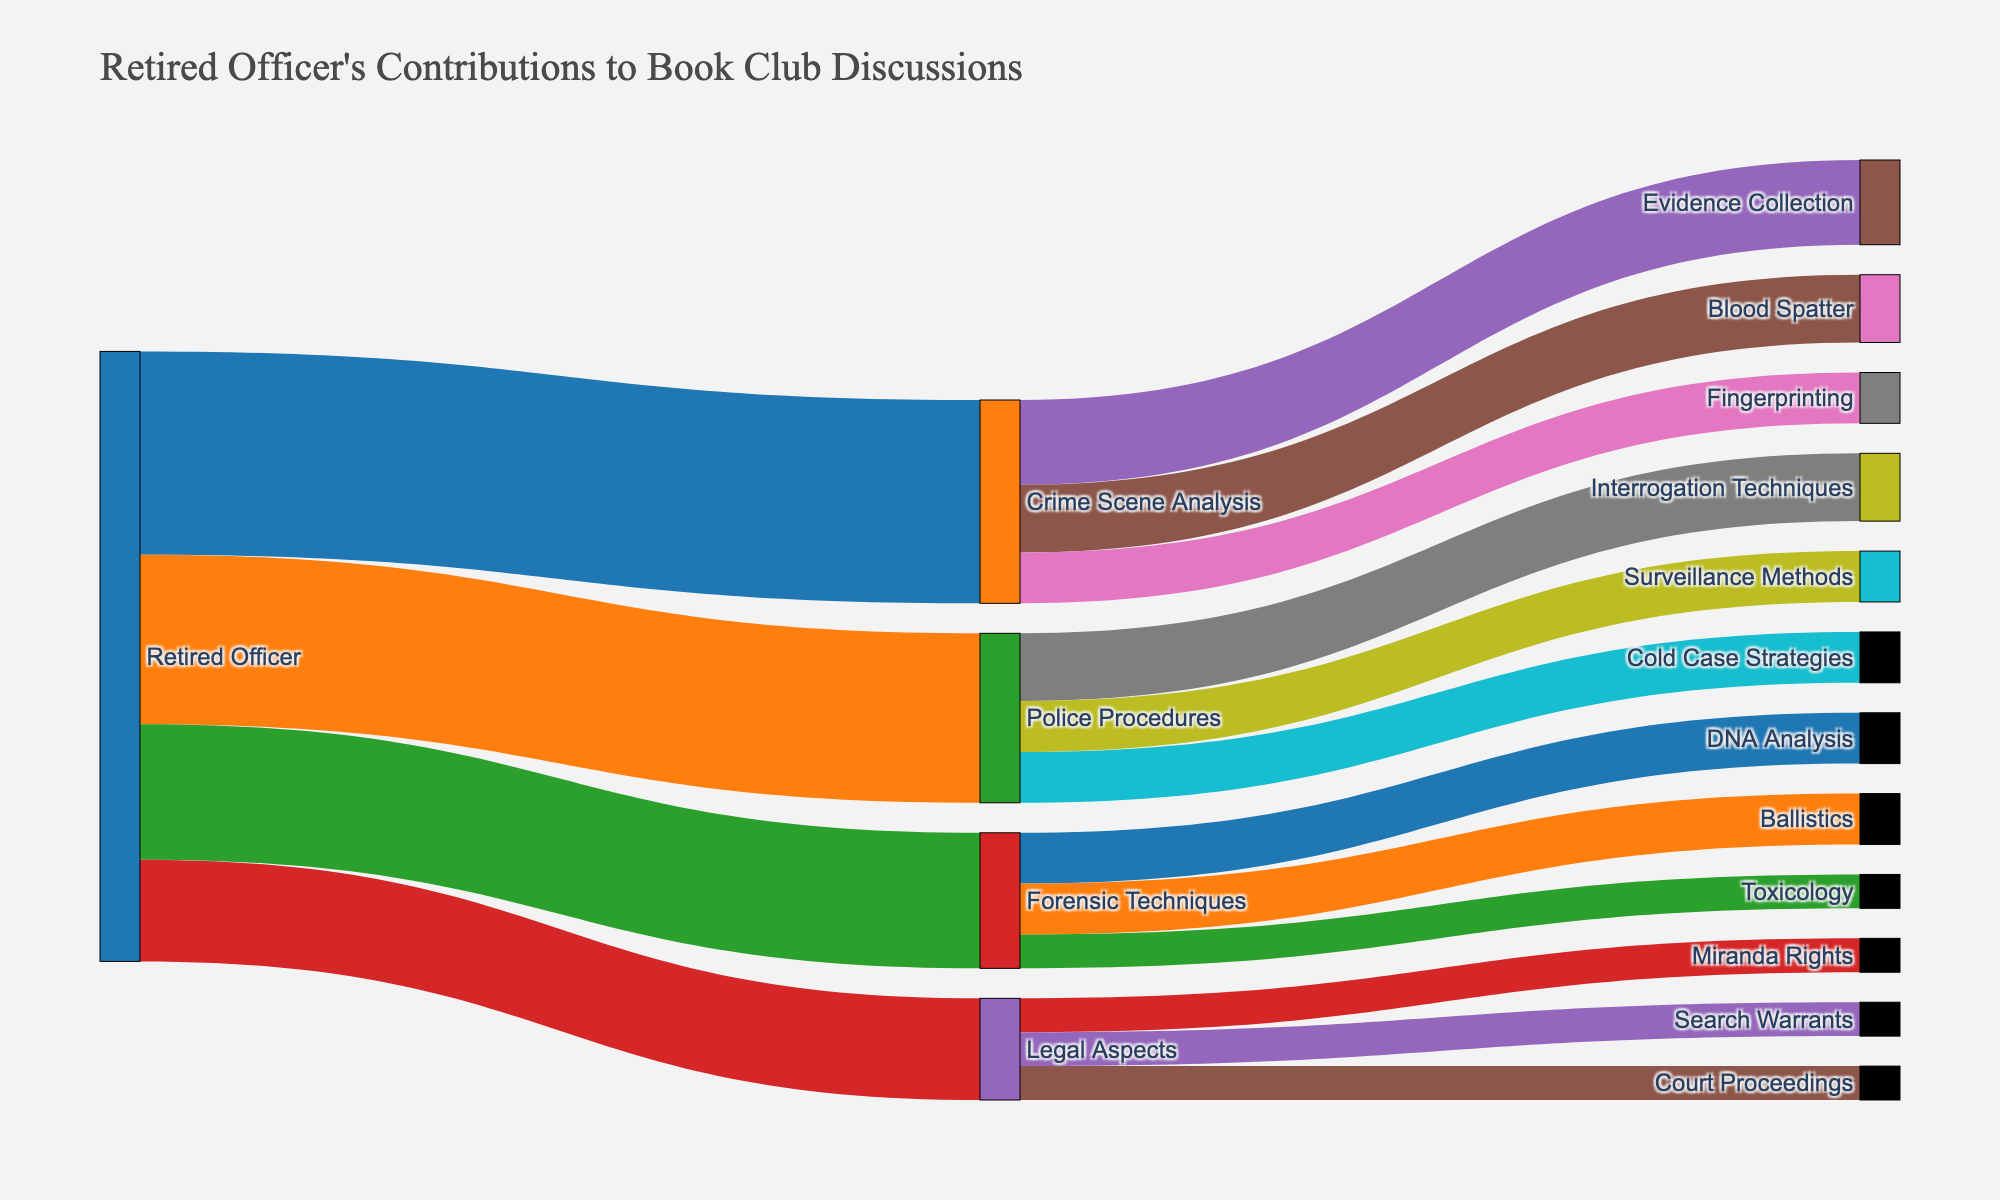What's the main topic the retired officer contributes to the most? The Sankey diagram shows the frequency breakdown of the retired officer's contributions by topic. The segment with the highest value indicates the main topic.
Answer: Crime Scene Analysis How many contributions were made by the retired officer to Forensic Techniques? To find this, look for the total value attributed to Forensic Techniques in the diagram. The values for DNA Analysis, Ballistics, and Toxicology combine to give the total.
Answer: 8 Which specific aspect of Crime Scene Analysis has received the highest contributions? For each sub-topic under Crime Scene Analysis in the diagram, compare the frequency values. The highest frequency indicates the most focused aspect.
Answer: Evidence Collection Compare the contributions to Interrogation Techniques and Cold Case Strategies. Which one received more contributions? Look at the segments connecting Police Procedures to Interrogation Techniques and Cold Case Strategies. Compare their frequency values.
Answer: Interrogation Techniques How do the contributions to Legal Aspects compare to those to Forensic Techniques? Summarize the frequencies for Legal Aspects sub-topics and Forensic Techniques sub-topics. Compare the totals to see which one has more contributions.
Answer: Legal Aspects have fewer contributions than Forensic Techniques Calculate the total frequency of contributions made by the retired officer across all topics. Sum up all the frequency values given in the diagram for the retired officer’s contributions: 12 + 10 + 8 + 6.
Answer: 36 How many segments in the diagram represent contributions to sub-topics under Crime Scene Analysis? Count the number of connections originating from Crime Scene Analysis to its sub-topics in the diagram.
Answer: 3 Which color is most frequently used in the diagram? Identify and count the colors associated with the links and nodes in the diagram. The most frequently appearing color is the answer.
Answer: Blue If the retired officer's contributions to book club discussions were evenly distributed among all the topics, how much would each topic receive? Distribute the total frequency of contributions (36) equally among the 4 main topics. 36 divided by 4 gives the answer.
Answer: 9 